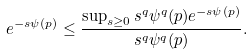<formula> <loc_0><loc_0><loc_500><loc_500>e ^ { - s \psi ( p ) } \leq \frac { \sup _ { s \geq 0 } s ^ { q } \psi ^ { q } ( p ) e ^ { - s \psi ( p ) } } { s ^ { q } \psi ^ { q } ( p ) } .</formula> 